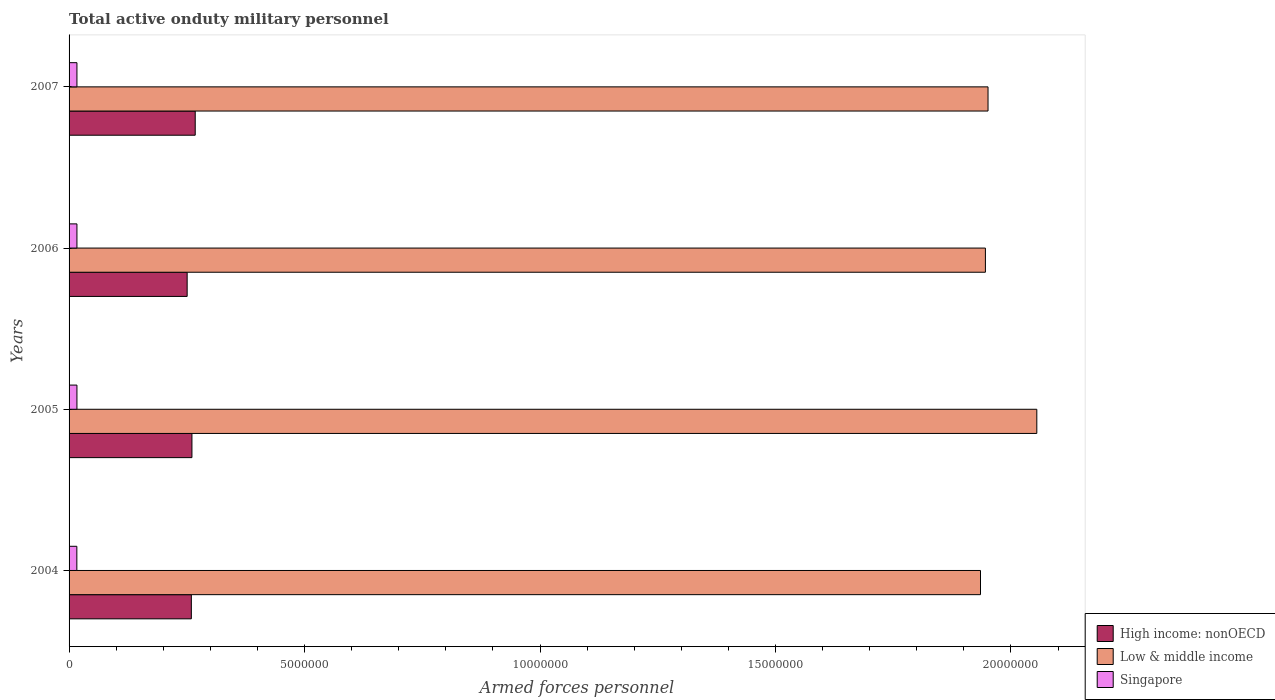How many groups of bars are there?
Your answer should be very brief. 4. How many bars are there on the 1st tick from the top?
Your answer should be very brief. 3. How many bars are there on the 1st tick from the bottom?
Your answer should be very brief. 3. What is the number of armed forces personnel in High income: nonOECD in 2004?
Make the answer very short. 2.60e+06. Across all years, what is the maximum number of armed forces personnel in Singapore?
Give a very brief answer. 1.67e+05. Across all years, what is the minimum number of armed forces personnel in Low & middle income?
Provide a short and direct response. 1.94e+07. In which year was the number of armed forces personnel in Singapore maximum?
Keep it short and to the point. 2005. In which year was the number of armed forces personnel in Low & middle income minimum?
Give a very brief answer. 2004. What is the total number of armed forces personnel in Low & middle income in the graph?
Your answer should be compact. 7.89e+07. What is the difference between the number of armed forces personnel in High income: nonOECD in 2005 and that in 2007?
Your answer should be very brief. -7.00e+04. What is the difference between the number of armed forces personnel in Low & middle income in 2006 and the number of armed forces personnel in High income: nonOECD in 2005?
Offer a very short reply. 1.68e+07. What is the average number of armed forces personnel in Low & middle income per year?
Your answer should be very brief. 1.97e+07. In the year 2005, what is the difference between the number of armed forces personnel in High income: nonOECD and number of armed forces personnel in Low & middle income?
Provide a succinct answer. -1.79e+07. What is the ratio of the number of armed forces personnel in Singapore in 2004 to that in 2006?
Make the answer very short. 0.99. What is the difference between the highest and the second highest number of armed forces personnel in Low & middle income?
Provide a short and direct response. 1.04e+06. What is the difference between the highest and the lowest number of armed forces personnel in High income: nonOECD?
Offer a very short reply. 1.71e+05. In how many years, is the number of armed forces personnel in Singapore greater than the average number of armed forces personnel in Singapore taken over all years?
Ensure brevity in your answer.  3. What does the 1st bar from the top in 2004 represents?
Keep it short and to the point. Singapore. What does the 3rd bar from the bottom in 2005 represents?
Make the answer very short. Singapore. Is it the case that in every year, the sum of the number of armed forces personnel in Low & middle income and number of armed forces personnel in Singapore is greater than the number of armed forces personnel in High income: nonOECD?
Your answer should be compact. Yes. How many bars are there?
Provide a succinct answer. 12. Are all the bars in the graph horizontal?
Keep it short and to the point. Yes. How many years are there in the graph?
Give a very brief answer. 4. Where does the legend appear in the graph?
Give a very brief answer. Bottom right. How many legend labels are there?
Offer a very short reply. 3. What is the title of the graph?
Provide a short and direct response. Total active onduty military personnel. Does "Albania" appear as one of the legend labels in the graph?
Make the answer very short. No. What is the label or title of the X-axis?
Provide a short and direct response. Armed forces personnel. What is the Armed forces personnel in High income: nonOECD in 2004?
Ensure brevity in your answer.  2.60e+06. What is the Armed forces personnel of Low & middle income in 2004?
Offer a very short reply. 1.94e+07. What is the Armed forces personnel in Singapore in 2004?
Make the answer very short. 1.65e+05. What is the Armed forces personnel in High income: nonOECD in 2005?
Your answer should be compact. 2.61e+06. What is the Armed forces personnel in Low & middle income in 2005?
Ensure brevity in your answer.  2.05e+07. What is the Armed forces personnel of Singapore in 2005?
Offer a terse response. 1.67e+05. What is the Armed forces personnel of High income: nonOECD in 2006?
Your response must be concise. 2.51e+06. What is the Armed forces personnel of Low & middle income in 2006?
Keep it short and to the point. 1.95e+07. What is the Armed forces personnel of Singapore in 2006?
Offer a terse response. 1.67e+05. What is the Armed forces personnel of High income: nonOECD in 2007?
Your response must be concise. 2.68e+06. What is the Armed forces personnel of Low & middle income in 2007?
Provide a short and direct response. 1.95e+07. What is the Armed forces personnel of Singapore in 2007?
Your answer should be compact. 1.67e+05. Across all years, what is the maximum Armed forces personnel in High income: nonOECD?
Offer a very short reply. 2.68e+06. Across all years, what is the maximum Armed forces personnel of Low & middle income?
Provide a short and direct response. 2.05e+07. Across all years, what is the maximum Armed forces personnel in Singapore?
Give a very brief answer. 1.67e+05. Across all years, what is the minimum Armed forces personnel in High income: nonOECD?
Offer a terse response. 2.51e+06. Across all years, what is the minimum Armed forces personnel in Low & middle income?
Give a very brief answer. 1.94e+07. Across all years, what is the minimum Armed forces personnel in Singapore?
Keep it short and to the point. 1.65e+05. What is the total Armed forces personnel of High income: nonOECD in the graph?
Your response must be concise. 1.04e+07. What is the total Armed forces personnel in Low & middle income in the graph?
Keep it short and to the point. 7.89e+07. What is the total Armed forces personnel in Singapore in the graph?
Keep it short and to the point. 6.66e+05. What is the difference between the Armed forces personnel in High income: nonOECD in 2004 and that in 2005?
Your answer should be compact. -1.26e+04. What is the difference between the Armed forces personnel in Low & middle income in 2004 and that in 2005?
Keep it short and to the point. -1.20e+06. What is the difference between the Armed forces personnel in Singapore in 2004 and that in 2005?
Give a very brief answer. -2000. What is the difference between the Armed forces personnel in High income: nonOECD in 2004 and that in 2006?
Offer a very short reply. 8.88e+04. What is the difference between the Armed forces personnel in Low & middle income in 2004 and that in 2006?
Give a very brief answer. -1.04e+05. What is the difference between the Armed forces personnel of Singapore in 2004 and that in 2006?
Provide a succinct answer. -2000. What is the difference between the Armed forces personnel of High income: nonOECD in 2004 and that in 2007?
Make the answer very short. -8.25e+04. What is the difference between the Armed forces personnel in Low & middle income in 2004 and that in 2007?
Provide a succinct answer. -1.60e+05. What is the difference between the Armed forces personnel of Singapore in 2004 and that in 2007?
Your answer should be compact. -2000. What is the difference between the Armed forces personnel in High income: nonOECD in 2005 and that in 2006?
Offer a very short reply. 1.01e+05. What is the difference between the Armed forces personnel in Low & middle income in 2005 and that in 2006?
Keep it short and to the point. 1.09e+06. What is the difference between the Armed forces personnel of Singapore in 2005 and that in 2006?
Ensure brevity in your answer.  0. What is the difference between the Armed forces personnel in High income: nonOECD in 2005 and that in 2007?
Provide a short and direct response. -7.00e+04. What is the difference between the Armed forces personnel of Low & middle income in 2005 and that in 2007?
Your answer should be compact. 1.04e+06. What is the difference between the Armed forces personnel of High income: nonOECD in 2006 and that in 2007?
Your answer should be compact. -1.71e+05. What is the difference between the Armed forces personnel in Low & middle income in 2006 and that in 2007?
Make the answer very short. -5.58e+04. What is the difference between the Armed forces personnel in High income: nonOECD in 2004 and the Armed forces personnel in Low & middle income in 2005?
Your answer should be very brief. -1.80e+07. What is the difference between the Armed forces personnel in High income: nonOECD in 2004 and the Armed forces personnel in Singapore in 2005?
Provide a succinct answer. 2.43e+06. What is the difference between the Armed forces personnel of Low & middle income in 2004 and the Armed forces personnel of Singapore in 2005?
Your answer should be very brief. 1.92e+07. What is the difference between the Armed forces personnel in High income: nonOECD in 2004 and the Armed forces personnel in Low & middle income in 2006?
Your answer should be very brief. -1.69e+07. What is the difference between the Armed forces personnel in High income: nonOECD in 2004 and the Armed forces personnel in Singapore in 2006?
Make the answer very short. 2.43e+06. What is the difference between the Armed forces personnel in Low & middle income in 2004 and the Armed forces personnel in Singapore in 2006?
Your answer should be very brief. 1.92e+07. What is the difference between the Armed forces personnel of High income: nonOECD in 2004 and the Armed forces personnel of Low & middle income in 2007?
Ensure brevity in your answer.  -1.69e+07. What is the difference between the Armed forces personnel in High income: nonOECD in 2004 and the Armed forces personnel in Singapore in 2007?
Your response must be concise. 2.43e+06. What is the difference between the Armed forces personnel of Low & middle income in 2004 and the Armed forces personnel of Singapore in 2007?
Make the answer very short. 1.92e+07. What is the difference between the Armed forces personnel of High income: nonOECD in 2005 and the Armed forces personnel of Low & middle income in 2006?
Ensure brevity in your answer.  -1.68e+07. What is the difference between the Armed forces personnel of High income: nonOECD in 2005 and the Armed forces personnel of Singapore in 2006?
Offer a very short reply. 2.44e+06. What is the difference between the Armed forces personnel in Low & middle income in 2005 and the Armed forces personnel in Singapore in 2006?
Your response must be concise. 2.04e+07. What is the difference between the Armed forces personnel of High income: nonOECD in 2005 and the Armed forces personnel of Low & middle income in 2007?
Make the answer very short. -1.69e+07. What is the difference between the Armed forces personnel in High income: nonOECD in 2005 and the Armed forces personnel in Singapore in 2007?
Make the answer very short. 2.44e+06. What is the difference between the Armed forces personnel of Low & middle income in 2005 and the Armed forces personnel of Singapore in 2007?
Your answer should be very brief. 2.04e+07. What is the difference between the Armed forces personnel in High income: nonOECD in 2006 and the Armed forces personnel in Low & middle income in 2007?
Offer a very short reply. -1.70e+07. What is the difference between the Armed forces personnel of High income: nonOECD in 2006 and the Armed forces personnel of Singapore in 2007?
Offer a very short reply. 2.34e+06. What is the difference between the Armed forces personnel in Low & middle income in 2006 and the Armed forces personnel in Singapore in 2007?
Keep it short and to the point. 1.93e+07. What is the average Armed forces personnel of High income: nonOECD per year?
Your answer should be compact. 2.60e+06. What is the average Armed forces personnel in Low & middle income per year?
Your answer should be very brief. 1.97e+07. What is the average Armed forces personnel in Singapore per year?
Ensure brevity in your answer.  1.66e+05. In the year 2004, what is the difference between the Armed forces personnel of High income: nonOECD and Armed forces personnel of Low & middle income?
Make the answer very short. -1.68e+07. In the year 2004, what is the difference between the Armed forces personnel in High income: nonOECD and Armed forces personnel in Singapore?
Offer a very short reply. 2.43e+06. In the year 2004, what is the difference between the Armed forces personnel in Low & middle income and Armed forces personnel in Singapore?
Provide a short and direct response. 1.92e+07. In the year 2005, what is the difference between the Armed forces personnel in High income: nonOECD and Armed forces personnel in Low & middle income?
Make the answer very short. -1.79e+07. In the year 2005, what is the difference between the Armed forces personnel of High income: nonOECD and Armed forces personnel of Singapore?
Your answer should be very brief. 2.44e+06. In the year 2005, what is the difference between the Armed forces personnel in Low & middle income and Armed forces personnel in Singapore?
Offer a very short reply. 2.04e+07. In the year 2006, what is the difference between the Armed forces personnel of High income: nonOECD and Armed forces personnel of Low & middle income?
Offer a very short reply. -1.69e+07. In the year 2006, what is the difference between the Armed forces personnel of High income: nonOECD and Armed forces personnel of Singapore?
Offer a terse response. 2.34e+06. In the year 2006, what is the difference between the Armed forces personnel of Low & middle income and Armed forces personnel of Singapore?
Ensure brevity in your answer.  1.93e+07. In the year 2007, what is the difference between the Armed forces personnel in High income: nonOECD and Armed forces personnel in Low & middle income?
Give a very brief answer. -1.68e+07. In the year 2007, what is the difference between the Armed forces personnel in High income: nonOECD and Armed forces personnel in Singapore?
Offer a terse response. 2.51e+06. In the year 2007, what is the difference between the Armed forces personnel of Low & middle income and Armed forces personnel of Singapore?
Your answer should be compact. 1.93e+07. What is the ratio of the Armed forces personnel in Low & middle income in 2004 to that in 2005?
Your answer should be compact. 0.94. What is the ratio of the Armed forces personnel in High income: nonOECD in 2004 to that in 2006?
Offer a terse response. 1.04. What is the ratio of the Armed forces personnel of Low & middle income in 2004 to that in 2006?
Your answer should be compact. 0.99. What is the ratio of the Armed forces personnel of Singapore in 2004 to that in 2006?
Offer a terse response. 0.99. What is the ratio of the Armed forces personnel in High income: nonOECD in 2004 to that in 2007?
Make the answer very short. 0.97. What is the ratio of the Armed forces personnel in Low & middle income in 2004 to that in 2007?
Make the answer very short. 0.99. What is the ratio of the Armed forces personnel in Singapore in 2004 to that in 2007?
Your answer should be compact. 0.99. What is the ratio of the Armed forces personnel in High income: nonOECD in 2005 to that in 2006?
Your response must be concise. 1.04. What is the ratio of the Armed forces personnel of Low & middle income in 2005 to that in 2006?
Give a very brief answer. 1.06. What is the ratio of the Armed forces personnel in High income: nonOECD in 2005 to that in 2007?
Provide a succinct answer. 0.97. What is the ratio of the Armed forces personnel in Low & middle income in 2005 to that in 2007?
Offer a terse response. 1.05. What is the ratio of the Armed forces personnel of Singapore in 2005 to that in 2007?
Give a very brief answer. 1. What is the ratio of the Armed forces personnel of High income: nonOECD in 2006 to that in 2007?
Offer a terse response. 0.94. What is the ratio of the Armed forces personnel of Singapore in 2006 to that in 2007?
Your answer should be very brief. 1. What is the difference between the highest and the second highest Armed forces personnel in High income: nonOECD?
Make the answer very short. 7.00e+04. What is the difference between the highest and the second highest Armed forces personnel of Low & middle income?
Ensure brevity in your answer.  1.04e+06. What is the difference between the highest and the second highest Armed forces personnel in Singapore?
Your response must be concise. 0. What is the difference between the highest and the lowest Armed forces personnel in High income: nonOECD?
Your answer should be very brief. 1.71e+05. What is the difference between the highest and the lowest Armed forces personnel in Low & middle income?
Provide a short and direct response. 1.20e+06. What is the difference between the highest and the lowest Armed forces personnel of Singapore?
Make the answer very short. 2000. 